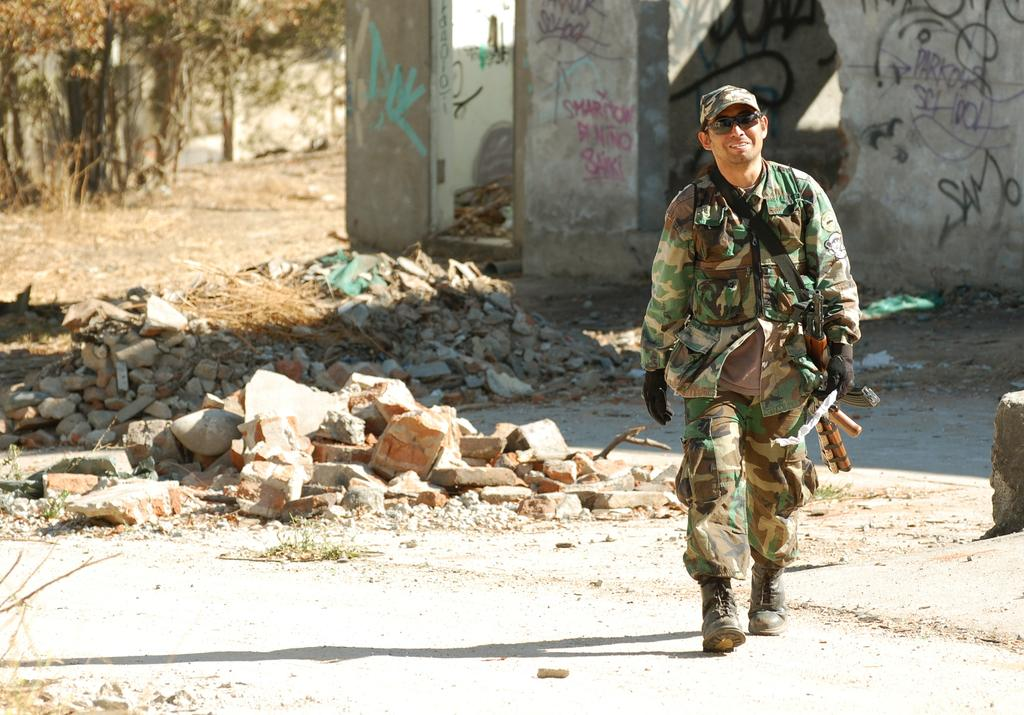Who is present in the image? There is a man in the image. What can be seen in the top left corner of the image? There are trees in the left top corner of the image. What is visible in the background of the image? There is a wall with text in the background of the image. What type of cake is being served in the image? There is no cake present in the image. 